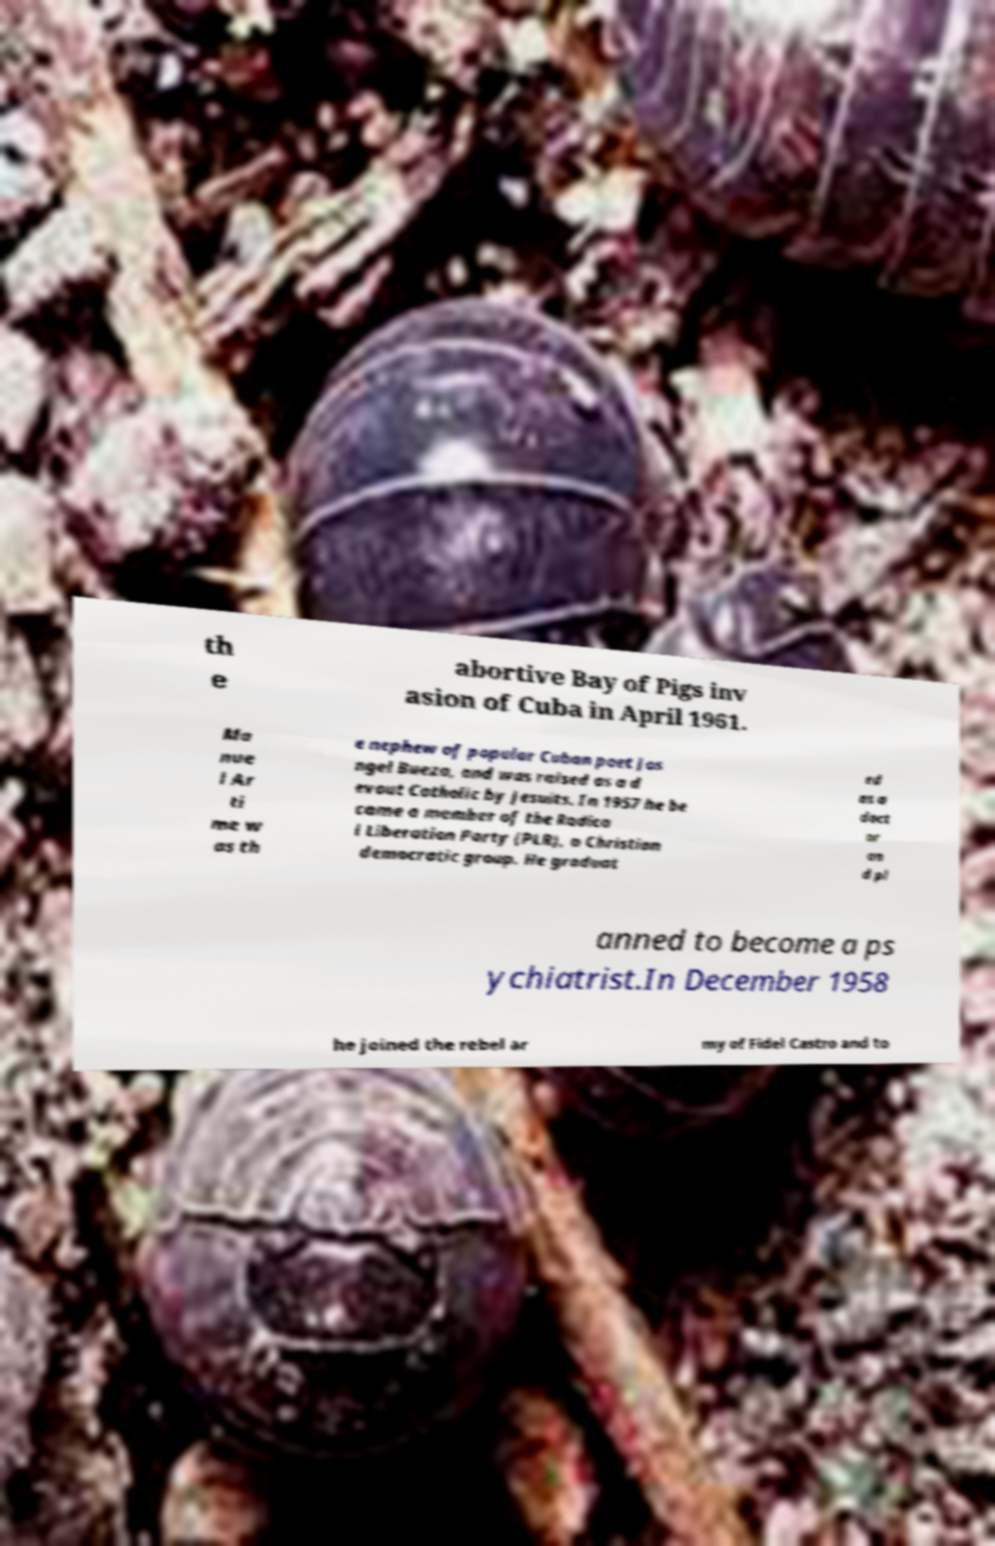Please identify and transcribe the text found in this image. th e abortive Bay of Pigs inv asion of Cuba in April 1961. Ma nue l Ar ti me w as th e nephew of popular Cuban poet Jos ngel Bueza, and was raised as a d evout Catholic by Jesuits. In 1957 he be came a member of the Radica l Liberation Party (PLR), a Christian democratic group. He graduat ed as a doct or an d pl anned to become a ps ychiatrist.In December 1958 he joined the rebel ar my of Fidel Castro and to 